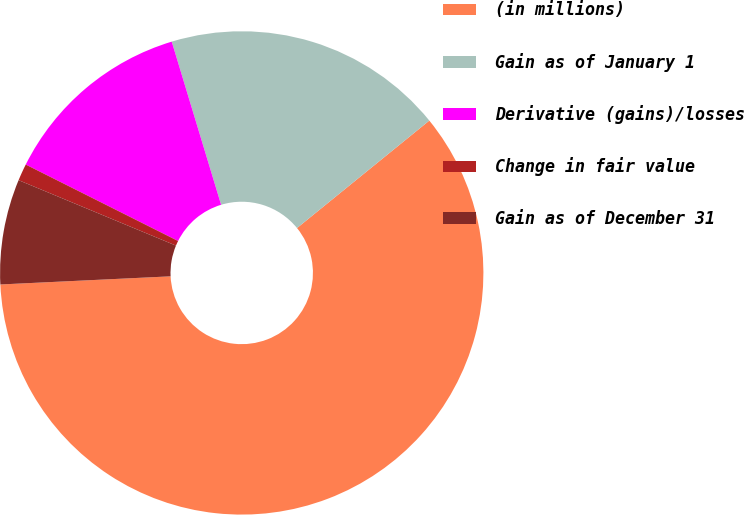Convert chart. <chart><loc_0><loc_0><loc_500><loc_500><pie_chart><fcel>(in millions)<fcel>Gain as of January 1<fcel>Derivative (gains)/losses<fcel>Change in fair value<fcel>Gain as of December 31<nl><fcel>60.09%<fcel>18.82%<fcel>12.92%<fcel>1.13%<fcel>7.03%<nl></chart> 